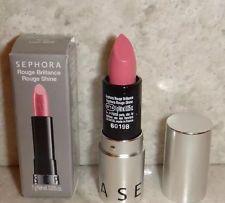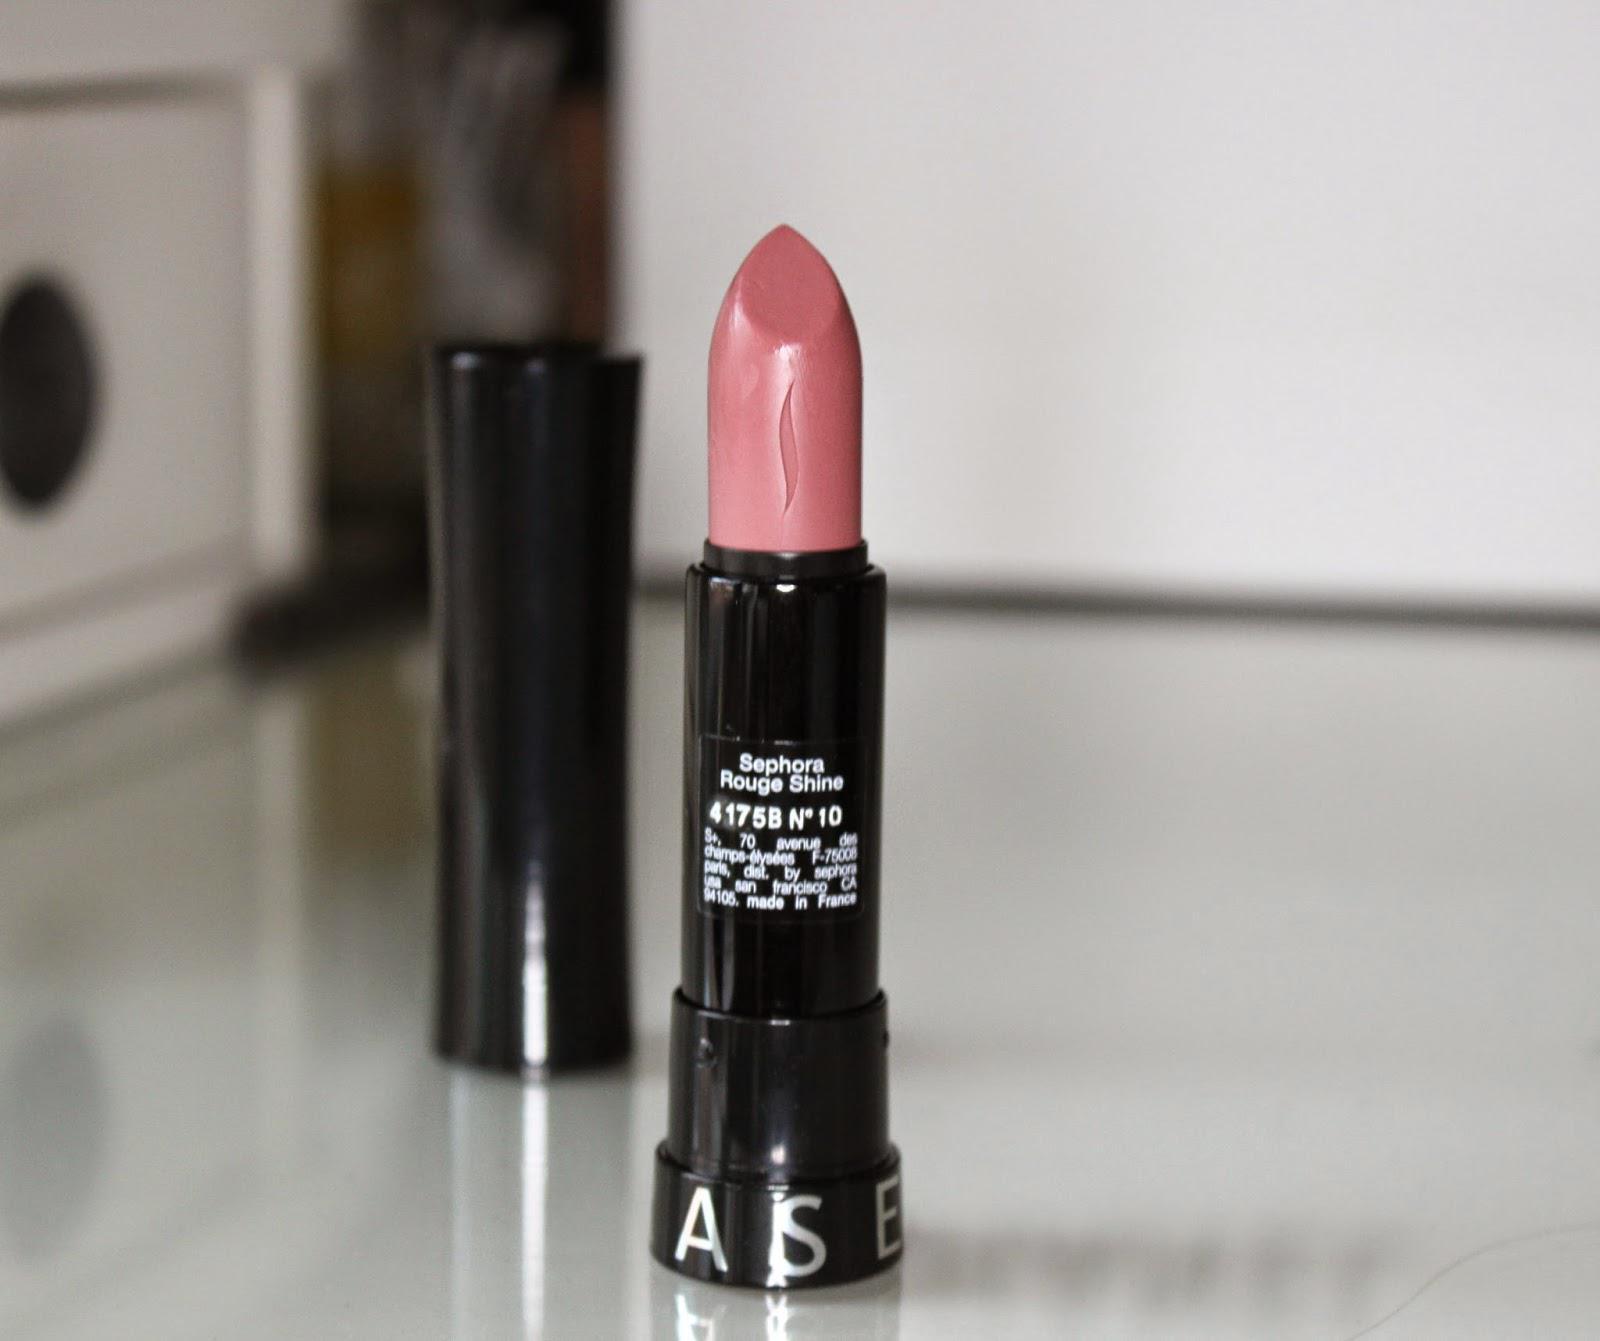The first image is the image on the left, the second image is the image on the right. Examine the images to the left and right. Is the description "One lipstick has a silver casing and the other has a black casing." accurate? Answer yes or no. Yes. 